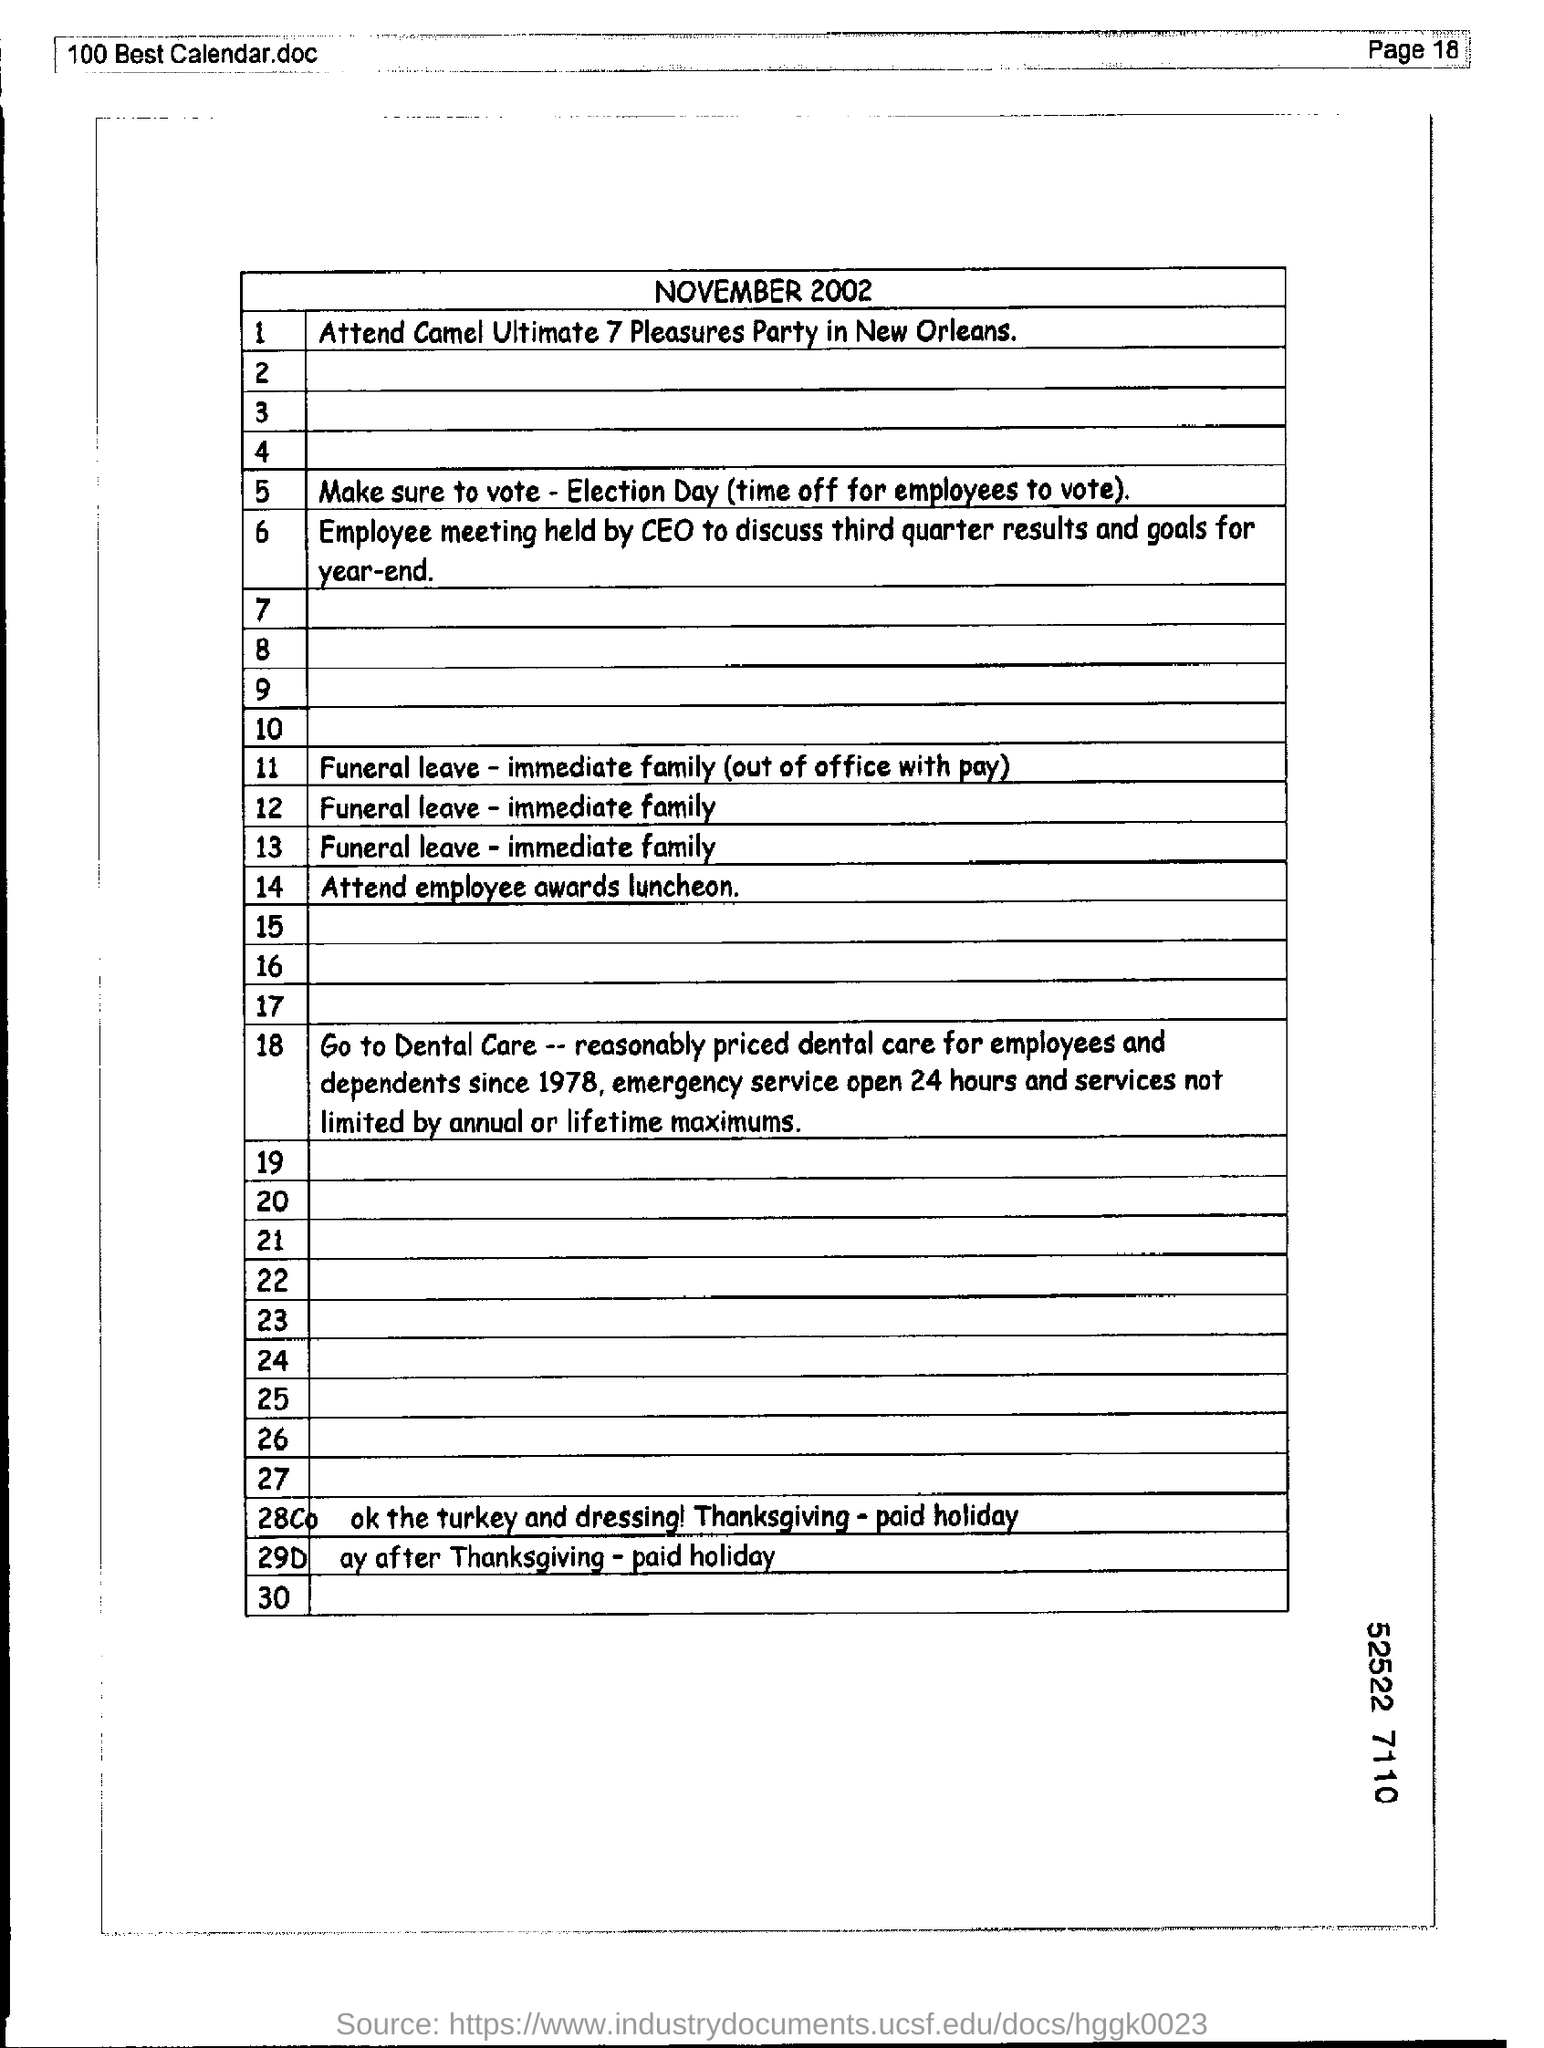Mention the page number at top right corner of the page ?
Offer a terse response. 18. What is the month and year mentioned in document ?
Your response must be concise. November 2002. 